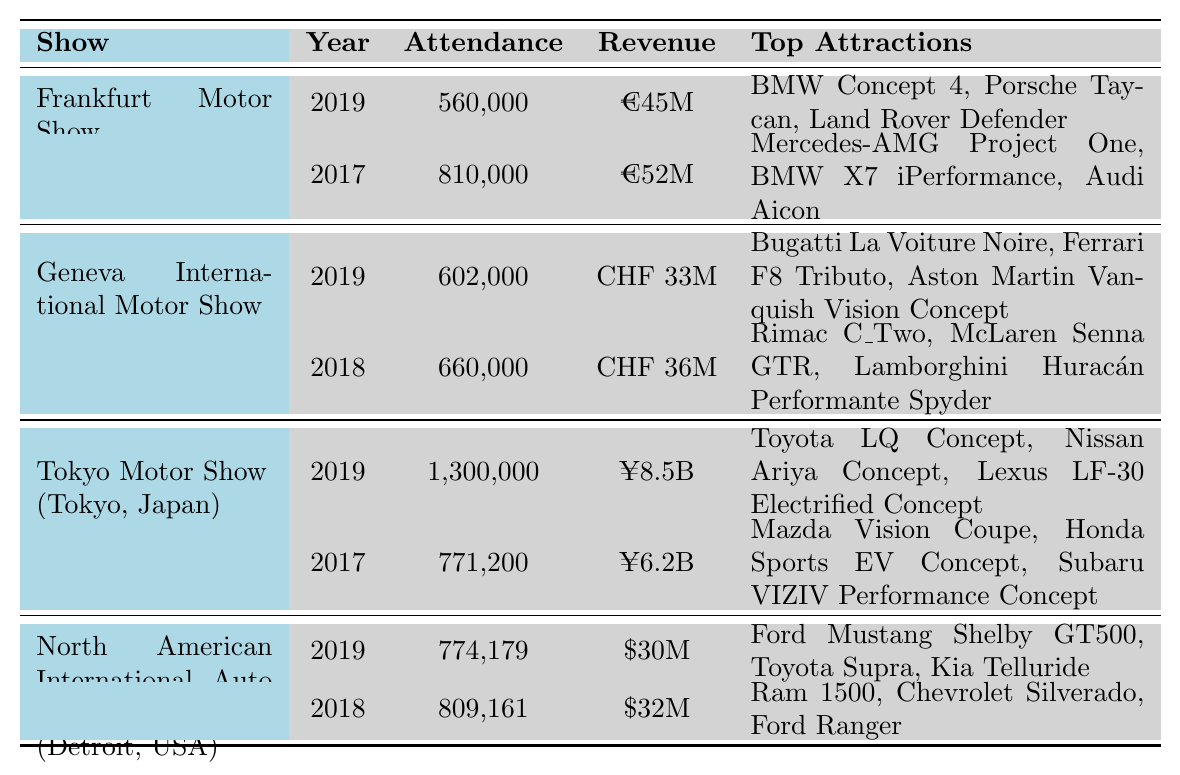What was the attendance at the Tokyo Motor Show in 2019? The table shows that the Tokyo Motor Show had an attendance of 1,300,000 in 2019.
Answer: 1,300,000 Which show had the highest revenue in 2017? By comparing the revenue figures for each show in 2017, Frankfurt Motor Show had the highest revenue of €52 million.
Answer: €52 million How many people attended the Geneva International Motor Show in 2018? According to the table, the attendance for the Geneva International Motor Show in 2018 was 660,000.
Answer: 660,000 What is the total attendance for the Frankfurt Motor Show across both years listed? The attendance for the Frankfurt Motor Show in 2019 is 560,000 and in 2017 is 810,000. Summing these gives 560,000 + 810,000 = 1,370,000.
Answer: 1,370,000 Did the attendance for the Tokyo Motor Show increase from 2017 to 2019? The attendance in 2017 was 771,200 and in 2019 it was 1,300,000. Since 1,300,000 is greater than 771,200, it indicates an increase.
Answer: Yes What was the average revenue of the North American International Auto Show for 2018 and 2019? The revenues for 2018 and 2019 are $32 million and $30 million respectively. The average revenue is calculated as (32 + 30) / 2 = 31 million.
Answer: $31 million Which auto show had the lowest attendance in the year 2019? In 2019, the Frankfurt Motor Show had an attendance of 560,000, while the other shows had higher attendances (Geneva: 602,000, Tokyo: 1,300,000, North American: 774,179). Therefore, Frankfurt had the lowest attendance.
Answer: Frankfurt Motor Show What were the top attractions for the Geneva International Motor Show in 2019? The table lists the top attractions for the Geneva International Motor Show in 2019 as Bugatti La Voiture Noire, Ferrari F8 Tributo, and Aston Martin Vanquish Vision Concept.
Answer: Bugatti La Voiture Noire, Ferrari F8 Tributo, Aston Martin Vanquish Vision Concept Which show had the second highest attendance in 2018? The attendance for the auto shows in 2018 were as follows: Geneva: 660,000, North American: 809,161. Therefore, Geneva International Motor Show had the second highest attendance after North American International Auto Show.
Answer: Geneva International Motor Show How much more revenue did the Tokyo Motor Show generate in 2019 compared to the Frankfurt Motor Show in the same year? The Tokyo Motor Show generated ¥8.5 billion in 2019 and the Frankfurt Motor Show generated €45 million. To compare, the values need to be converted to the same currency, which is complex here; therefore, based on the values presented, we can’t determine the difference accurately without further context.
Answer: Cannot determine without conversion 